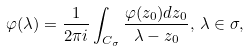Convert formula to latex. <formula><loc_0><loc_0><loc_500><loc_500>\varphi ( \lambda ) = \frac { 1 } { 2 \pi i } \int _ { C _ { \sigma } } \frac { \varphi ( z _ { 0 } ) d z _ { 0 } } { \lambda - z _ { 0 } } , \, \lambda \in \sigma ,</formula> 